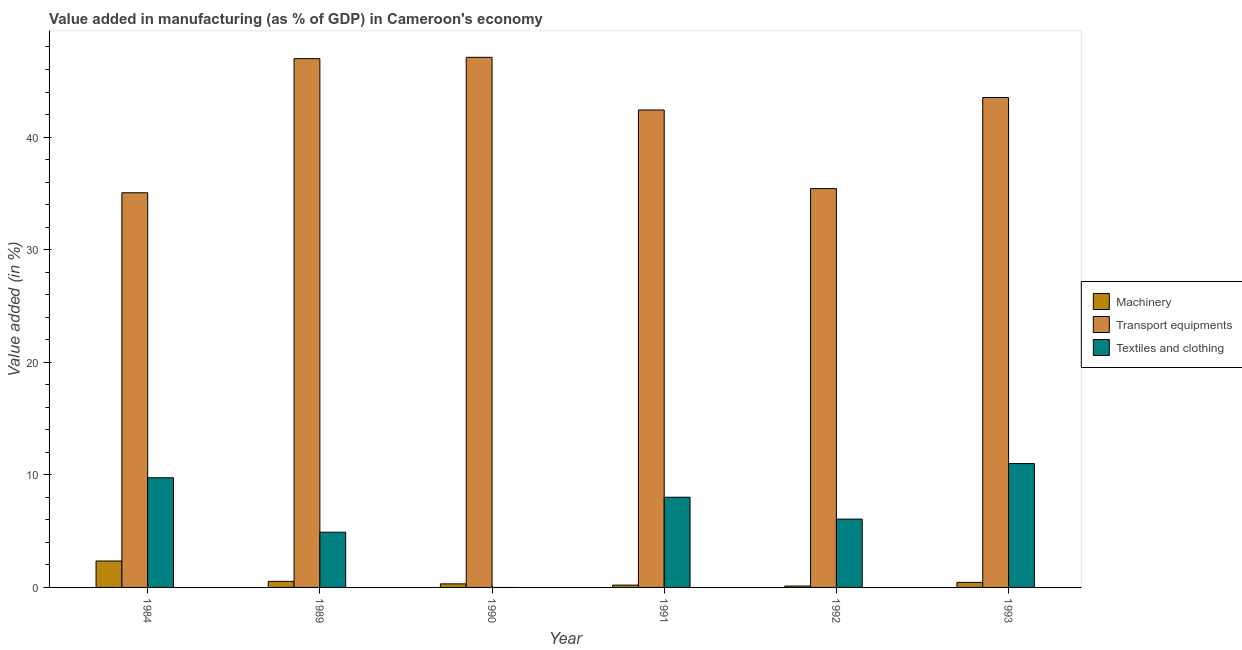Are the number of bars on each tick of the X-axis equal?
Provide a short and direct response. No. How many bars are there on the 6th tick from the left?
Ensure brevity in your answer.  3. How many bars are there on the 3rd tick from the right?
Provide a succinct answer. 3. What is the value added in manufacturing transport equipments in 1991?
Offer a very short reply. 42.4. Across all years, what is the maximum value added in manufacturing machinery?
Offer a terse response. 2.35. Across all years, what is the minimum value added in manufacturing transport equipments?
Keep it short and to the point. 35.05. What is the total value added in manufacturing machinery in the graph?
Give a very brief answer. 3.98. What is the difference between the value added in manufacturing transport equipments in 1990 and that in 1991?
Provide a short and direct response. 4.68. What is the difference between the value added in manufacturing textile and clothing in 1989 and the value added in manufacturing machinery in 1993?
Offer a very short reply. -6.1. What is the average value added in manufacturing transport equipments per year?
Provide a succinct answer. 41.74. What is the ratio of the value added in manufacturing machinery in 1989 to that in 1990?
Provide a short and direct response. 1.7. Is the value added in manufacturing textile and clothing in 1984 less than that in 1993?
Provide a succinct answer. Yes. What is the difference between the highest and the second highest value added in manufacturing machinery?
Your answer should be very brief. 1.81. What is the difference between the highest and the lowest value added in manufacturing machinery?
Your answer should be very brief. 2.22. In how many years, is the value added in manufacturing textile and clothing greater than the average value added in manufacturing textile and clothing taken over all years?
Provide a succinct answer. 3. Are all the bars in the graph horizontal?
Offer a terse response. No. What is the difference between two consecutive major ticks on the Y-axis?
Make the answer very short. 10. Does the graph contain any zero values?
Make the answer very short. Yes. Where does the legend appear in the graph?
Offer a terse response. Center right. How many legend labels are there?
Provide a short and direct response. 3. What is the title of the graph?
Make the answer very short. Value added in manufacturing (as % of GDP) in Cameroon's economy. Does "Natural Gas" appear as one of the legend labels in the graph?
Make the answer very short. No. What is the label or title of the X-axis?
Your response must be concise. Year. What is the label or title of the Y-axis?
Provide a short and direct response. Value added (in %). What is the Value added (in %) in Machinery in 1984?
Keep it short and to the point. 2.35. What is the Value added (in %) in Transport equipments in 1984?
Make the answer very short. 35.05. What is the Value added (in %) of Textiles and clothing in 1984?
Provide a short and direct response. 9.74. What is the Value added (in %) of Machinery in 1989?
Keep it short and to the point. 0.54. What is the Value added (in %) of Transport equipments in 1989?
Make the answer very short. 46.96. What is the Value added (in %) in Textiles and clothing in 1989?
Give a very brief answer. 4.9. What is the Value added (in %) in Machinery in 1990?
Offer a very short reply. 0.32. What is the Value added (in %) of Transport equipments in 1990?
Your answer should be very brief. 47.08. What is the Value added (in %) of Textiles and clothing in 1990?
Provide a succinct answer. 0. What is the Value added (in %) of Machinery in 1991?
Offer a terse response. 0.21. What is the Value added (in %) of Transport equipments in 1991?
Offer a terse response. 42.4. What is the Value added (in %) of Textiles and clothing in 1991?
Your response must be concise. 8.01. What is the Value added (in %) of Machinery in 1992?
Keep it short and to the point. 0.12. What is the Value added (in %) of Transport equipments in 1992?
Your answer should be very brief. 35.42. What is the Value added (in %) in Textiles and clothing in 1992?
Ensure brevity in your answer.  6.07. What is the Value added (in %) in Machinery in 1993?
Make the answer very short. 0.45. What is the Value added (in %) of Transport equipments in 1993?
Ensure brevity in your answer.  43.51. What is the Value added (in %) in Textiles and clothing in 1993?
Your response must be concise. 11. Across all years, what is the maximum Value added (in %) of Machinery?
Your response must be concise. 2.35. Across all years, what is the maximum Value added (in %) in Transport equipments?
Make the answer very short. 47.08. Across all years, what is the maximum Value added (in %) of Textiles and clothing?
Your response must be concise. 11. Across all years, what is the minimum Value added (in %) of Machinery?
Your answer should be compact. 0.12. Across all years, what is the minimum Value added (in %) of Transport equipments?
Ensure brevity in your answer.  35.05. Across all years, what is the minimum Value added (in %) in Textiles and clothing?
Make the answer very short. 0. What is the total Value added (in %) of Machinery in the graph?
Give a very brief answer. 3.98. What is the total Value added (in %) in Transport equipments in the graph?
Offer a terse response. 250.43. What is the total Value added (in %) in Textiles and clothing in the graph?
Keep it short and to the point. 39.72. What is the difference between the Value added (in %) in Machinery in 1984 and that in 1989?
Ensure brevity in your answer.  1.81. What is the difference between the Value added (in %) of Transport equipments in 1984 and that in 1989?
Your response must be concise. -11.91. What is the difference between the Value added (in %) of Textiles and clothing in 1984 and that in 1989?
Offer a terse response. 4.84. What is the difference between the Value added (in %) in Machinery in 1984 and that in 1990?
Your answer should be compact. 2.03. What is the difference between the Value added (in %) of Transport equipments in 1984 and that in 1990?
Offer a very short reply. -12.03. What is the difference between the Value added (in %) of Machinery in 1984 and that in 1991?
Your answer should be very brief. 2.14. What is the difference between the Value added (in %) of Transport equipments in 1984 and that in 1991?
Give a very brief answer. -7.35. What is the difference between the Value added (in %) of Textiles and clothing in 1984 and that in 1991?
Provide a succinct answer. 1.73. What is the difference between the Value added (in %) in Machinery in 1984 and that in 1992?
Offer a very short reply. 2.22. What is the difference between the Value added (in %) of Transport equipments in 1984 and that in 1992?
Provide a succinct answer. -0.37. What is the difference between the Value added (in %) of Textiles and clothing in 1984 and that in 1992?
Your answer should be very brief. 3.67. What is the difference between the Value added (in %) of Machinery in 1984 and that in 1993?
Your answer should be compact. 1.9. What is the difference between the Value added (in %) in Transport equipments in 1984 and that in 1993?
Keep it short and to the point. -8.46. What is the difference between the Value added (in %) of Textiles and clothing in 1984 and that in 1993?
Your answer should be very brief. -1.26. What is the difference between the Value added (in %) of Machinery in 1989 and that in 1990?
Provide a short and direct response. 0.22. What is the difference between the Value added (in %) of Transport equipments in 1989 and that in 1990?
Provide a short and direct response. -0.12. What is the difference between the Value added (in %) in Transport equipments in 1989 and that in 1991?
Offer a very short reply. 4.56. What is the difference between the Value added (in %) in Textiles and clothing in 1989 and that in 1991?
Provide a short and direct response. -3.11. What is the difference between the Value added (in %) of Machinery in 1989 and that in 1992?
Keep it short and to the point. 0.42. What is the difference between the Value added (in %) in Transport equipments in 1989 and that in 1992?
Ensure brevity in your answer.  11.54. What is the difference between the Value added (in %) of Textiles and clothing in 1989 and that in 1992?
Make the answer very short. -1.16. What is the difference between the Value added (in %) of Machinery in 1989 and that in 1993?
Your answer should be compact. 0.09. What is the difference between the Value added (in %) of Transport equipments in 1989 and that in 1993?
Offer a terse response. 3.45. What is the difference between the Value added (in %) of Textiles and clothing in 1989 and that in 1993?
Your answer should be compact. -6.1. What is the difference between the Value added (in %) in Machinery in 1990 and that in 1991?
Your answer should be very brief. 0.11. What is the difference between the Value added (in %) in Transport equipments in 1990 and that in 1991?
Your response must be concise. 4.68. What is the difference between the Value added (in %) of Machinery in 1990 and that in 1992?
Your response must be concise. 0.19. What is the difference between the Value added (in %) of Transport equipments in 1990 and that in 1992?
Your answer should be very brief. 11.66. What is the difference between the Value added (in %) of Machinery in 1990 and that in 1993?
Ensure brevity in your answer.  -0.13. What is the difference between the Value added (in %) of Transport equipments in 1990 and that in 1993?
Provide a succinct answer. 3.57. What is the difference between the Value added (in %) in Machinery in 1991 and that in 1992?
Offer a very short reply. 0.08. What is the difference between the Value added (in %) of Transport equipments in 1991 and that in 1992?
Provide a short and direct response. 6.98. What is the difference between the Value added (in %) in Textiles and clothing in 1991 and that in 1992?
Make the answer very short. 1.94. What is the difference between the Value added (in %) of Machinery in 1991 and that in 1993?
Offer a terse response. -0.24. What is the difference between the Value added (in %) in Transport equipments in 1991 and that in 1993?
Your response must be concise. -1.11. What is the difference between the Value added (in %) in Textiles and clothing in 1991 and that in 1993?
Offer a terse response. -2.99. What is the difference between the Value added (in %) of Machinery in 1992 and that in 1993?
Give a very brief answer. -0.33. What is the difference between the Value added (in %) of Transport equipments in 1992 and that in 1993?
Offer a very short reply. -8.09. What is the difference between the Value added (in %) of Textiles and clothing in 1992 and that in 1993?
Your answer should be very brief. -4.93. What is the difference between the Value added (in %) of Machinery in 1984 and the Value added (in %) of Transport equipments in 1989?
Provide a short and direct response. -44.62. What is the difference between the Value added (in %) of Machinery in 1984 and the Value added (in %) of Textiles and clothing in 1989?
Offer a very short reply. -2.56. What is the difference between the Value added (in %) in Transport equipments in 1984 and the Value added (in %) in Textiles and clothing in 1989?
Your response must be concise. 30.15. What is the difference between the Value added (in %) in Machinery in 1984 and the Value added (in %) in Transport equipments in 1990?
Offer a terse response. -44.73. What is the difference between the Value added (in %) of Machinery in 1984 and the Value added (in %) of Transport equipments in 1991?
Your response must be concise. -40.06. What is the difference between the Value added (in %) in Machinery in 1984 and the Value added (in %) in Textiles and clothing in 1991?
Provide a short and direct response. -5.66. What is the difference between the Value added (in %) of Transport equipments in 1984 and the Value added (in %) of Textiles and clothing in 1991?
Ensure brevity in your answer.  27.04. What is the difference between the Value added (in %) of Machinery in 1984 and the Value added (in %) of Transport equipments in 1992?
Provide a succinct answer. -33.08. What is the difference between the Value added (in %) of Machinery in 1984 and the Value added (in %) of Textiles and clothing in 1992?
Offer a terse response. -3.72. What is the difference between the Value added (in %) of Transport equipments in 1984 and the Value added (in %) of Textiles and clothing in 1992?
Your answer should be very brief. 28.98. What is the difference between the Value added (in %) of Machinery in 1984 and the Value added (in %) of Transport equipments in 1993?
Provide a short and direct response. -41.17. What is the difference between the Value added (in %) of Machinery in 1984 and the Value added (in %) of Textiles and clothing in 1993?
Your response must be concise. -8.65. What is the difference between the Value added (in %) in Transport equipments in 1984 and the Value added (in %) in Textiles and clothing in 1993?
Your answer should be compact. 24.05. What is the difference between the Value added (in %) of Machinery in 1989 and the Value added (in %) of Transport equipments in 1990?
Ensure brevity in your answer.  -46.54. What is the difference between the Value added (in %) in Machinery in 1989 and the Value added (in %) in Transport equipments in 1991?
Give a very brief answer. -41.86. What is the difference between the Value added (in %) in Machinery in 1989 and the Value added (in %) in Textiles and clothing in 1991?
Your response must be concise. -7.47. What is the difference between the Value added (in %) of Transport equipments in 1989 and the Value added (in %) of Textiles and clothing in 1991?
Give a very brief answer. 38.95. What is the difference between the Value added (in %) of Machinery in 1989 and the Value added (in %) of Transport equipments in 1992?
Give a very brief answer. -34.89. What is the difference between the Value added (in %) of Machinery in 1989 and the Value added (in %) of Textiles and clothing in 1992?
Your response must be concise. -5.53. What is the difference between the Value added (in %) of Transport equipments in 1989 and the Value added (in %) of Textiles and clothing in 1992?
Offer a very short reply. 40.9. What is the difference between the Value added (in %) in Machinery in 1989 and the Value added (in %) in Transport equipments in 1993?
Make the answer very short. -42.97. What is the difference between the Value added (in %) of Machinery in 1989 and the Value added (in %) of Textiles and clothing in 1993?
Provide a succinct answer. -10.46. What is the difference between the Value added (in %) of Transport equipments in 1989 and the Value added (in %) of Textiles and clothing in 1993?
Your answer should be very brief. 35.96. What is the difference between the Value added (in %) of Machinery in 1990 and the Value added (in %) of Transport equipments in 1991?
Your answer should be compact. -42.09. What is the difference between the Value added (in %) in Machinery in 1990 and the Value added (in %) in Textiles and clothing in 1991?
Keep it short and to the point. -7.69. What is the difference between the Value added (in %) of Transport equipments in 1990 and the Value added (in %) of Textiles and clothing in 1991?
Your response must be concise. 39.07. What is the difference between the Value added (in %) in Machinery in 1990 and the Value added (in %) in Transport equipments in 1992?
Your answer should be compact. -35.11. What is the difference between the Value added (in %) in Machinery in 1990 and the Value added (in %) in Textiles and clothing in 1992?
Give a very brief answer. -5.75. What is the difference between the Value added (in %) in Transport equipments in 1990 and the Value added (in %) in Textiles and clothing in 1992?
Offer a very short reply. 41.01. What is the difference between the Value added (in %) in Machinery in 1990 and the Value added (in %) in Transport equipments in 1993?
Your answer should be very brief. -43.2. What is the difference between the Value added (in %) in Machinery in 1990 and the Value added (in %) in Textiles and clothing in 1993?
Offer a terse response. -10.68. What is the difference between the Value added (in %) of Transport equipments in 1990 and the Value added (in %) of Textiles and clothing in 1993?
Your answer should be very brief. 36.08. What is the difference between the Value added (in %) in Machinery in 1991 and the Value added (in %) in Transport equipments in 1992?
Your answer should be compact. -35.22. What is the difference between the Value added (in %) of Machinery in 1991 and the Value added (in %) of Textiles and clothing in 1992?
Your response must be concise. -5.86. What is the difference between the Value added (in %) of Transport equipments in 1991 and the Value added (in %) of Textiles and clothing in 1992?
Your answer should be compact. 36.34. What is the difference between the Value added (in %) in Machinery in 1991 and the Value added (in %) in Transport equipments in 1993?
Your answer should be very brief. -43.31. What is the difference between the Value added (in %) of Machinery in 1991 and the Value added (in %) of Textiles and clothing in 1993?
Give a very brief answer. -10.79. What is the difference between the Value added (in %) in Transport equipments in 1991 and the Value added (in %) in Textiles and clothing in 1993?
Ensure brevity in your answer.  31.4. What is the difference between the Value added (in %) of Machinery in 1992 and the Value added (in %) of Transport equipments in 1993?
Provide a short and direct response. -43.39. What is the difference between the Value added (in %) in Machinery in 1992 and the Value added (in %) in Textiles and clothing in 1993?
Your answer should be compact. -10.88. What is the difference between the Value added (in %) in Transport equipments in 1992 and the Value added (in %) in Textiles and clothing in 1993?
Offer a very short reply. 24.43. What is the average Value added (in %) of Machinery per year?
Make the answer very short. 0.66. What is the average Value added (in %) in Transport equipments per year?
Your answer should be compact. 41.74. What is the average Value added (in %) in Textiles and clothing per year?
Your answer should be compact. 6.62. In the year 1984, what is the difference between the Value added (in %) in Machinery and Value added (in %) in Transport equipments?
Offer a terse response. -32.7. In the year 1984, what is the difference between the Value added (in %) in Machinery and Value added (in %) in Textiles and clothing?
Keep it short and to the point. -7.39. In the year 1984, what is the difference between the Value added (in %) of Transport equipments and Value added (in %) of Textiles and clothing?
Give a very brief answer. 25.31. In the year 1989, what is the difference between the Value added (in %) of Machinery and Value added (in %) of Transport equipments?
Offer a very short reply. -46.42. In the year 1989, what is the difference between the Value added (in %) of Machinery and Value added (in %) of Textiles and clothing?
Provide a short and direct response. -4.36. In the year 1989, what is the difference between the Value added (in %) in Transport equipments and Value added (in %) in Textiles and clothing?
Offer a very short reply. 42.06. In the year 1990, what is the difference between the Value added (in %) in Machinery and Value added (in %) in Transport equipments?
Your answer should be compact. -46.76. In the year 1991, what is the difference between the Value added (in %) of Machinery and Value added (in %) of Transport equipments?
Provide a succinct answer. -42.2. In the year 1991, what is the difference between the Value added (in %) in Machinery and Value added (in %) in Textiles and clothing?
Your answer should be very brief. -7.8. In the year 1991, what is the difference between the Value added (in %) in Transport equipments and Value added (in %) in Textiles and clothing?
Your answer should be compact. 34.39. In the year 1992, what is the difference between the Value added (in %) of Machinery and Value added (in %) of Transport equipments?
Make the answer very short. -35.3. In the year 1992, what is the difference between the Value added (in %) of Machinery and Value added (in %) of Textiles and clothing?
Your answer should be compact. -5.94. In the year 1992, what is the difference between the Value added (in %) in Transport equipments and Value added (in %) in Textiles and clothing?
Your response must be concise. 29.36. In the year 1993, what is the difference between the Value added (in %) in Machinery and Value added (in %) in Transport equipments?
Your response must be concise. -43.06. In the year 1993, what is the difference between the Value added (in %) in Machinery and Value added (in %) in Textiles and clothing?
Your answer should be compact. -10.55. In the year 1993, what is the difference between the Value added (in %) of Transport equipments and Value added (in %) of Textiles and clothing?
Your answer should be very brief. 32.51. What is the ratio of the Value added (in %) of Machinery in 1984 to that in 1989?
Your response must be concise. 4.35. What is the ratio of the Value added (in %) in Transport equipments in 1984 to that in 1989?
Your answer should be compact. 0.75. What is the ratio of the Value added (in %) in Textiles and clothing in 1984 to that in 1989?
Keep it short and to the point. 1.99. What is the ratio of the Value added (in %) in Machinery in 1984 to that in 1990?
Ensure brevity in your answer.  7.42. What is the ratio of the Value added (in %) of Transport equipments in 1984 to that in 1990?
Give a very brief answer. 0.74. What is the ratio of the Value added (in %) of Machinery in 1984 to that in 1991?
Your response must be concise. 11.41. What is the ratio of the Value added (in %) of Transport equipments in 1984 to that in 1991?
Give a very brief answer. 0.83. What is the ratio of the Value added (in %) of Textiles and clothing in 1984 to that in 1991?
Offer a very short reply. 1.22. What is the ratio of the Value added (in %) in Machinery in 1984 to that in 1992?
Offer a terse response. 19.08. What is the ratio of the Value added (in %) of Transport equipments in 1984 to that in 1992?
Your response must be concise. 0.99. What is the ratio of the Value added (in %) of Textiles and clothing in 1984 to that in 1992?
Make the answer very short. 1.61. What is the ratio of the Value added (in %) of Machinery in 1984 to that in 1993?
Provide a succinct answer. 5.23. What is the ratio of the Value added (in %) in Transport equipments in 1984 to that in 1993?
Ensure brevity in your answer.  0.81. What is the ratio of the Value added (in %) in Textiles and clothing in 1984 to that in 1993?
Ensure brevity in your answer.  0.89. What is the ratio of the Value added (in %) of Machinery in 1989 to that in 1990?
Your answer should be compact. 1.7. What is the ratio of the Value added (in %) in Transport equipments in 1989 to that in 1990?
Your answer should be very brief. 1. What is the ratio of the Value added (in %) in Machinery in 1989 to that in 1991?
Keep it short and to the point. 2.62. What is the ratio of the Value added (in %) of Transport equipments in 1989 to that in 1991?
Offer a very short reply. 1.11. What is the ratio of the Value added (in %) of Textiles and clothing in 1989 to that in 1991?
Your answer should be very brief. 0.61. What is the ratio of the Value added (in %) in Machinery in 1989 to that in 1992?
Give a very brief answer. 4.38. What is the ratio of the Value added (in %) of Transport equipments in 1989 to that in 1992?
Your answer should be very brief. 1.33. What is the ratio of the Value added (in %) of Textiles and clothing in 1989 to that in 1992?
Your answer should be very brief. 0.81. What is the ratio of the Value added (in %) of Machinery in 1989 to that in 1993?
Give a very brief answer. 1.2. What is the ratio of the Value added (in %) of Transport equipments in 1989 to that in 1993?
Your answer should be very brief. 1.08. What is the ratio of the Value added (in %) of Textiles and clothing in 1989 to that in 1993?
Give a very brief answer. 0.45. What is the ratio of the Value added (in %) in Machinery in 1990 to that in 1991?
Offer a very short reply. 1.54. What is the ratio of the Value added (in %) of Transport equipments in 1990 to that in 1991?
Your answer should be compact. 1.11. What is the ratio of the Value added (in %) of Machinery in 1990 to that in 1992?
Provide a succinct answer. 2.57. What is the ratio of the Value added (in %) in Transport equipments in 1990 to that in 1992?
Make the answer very short. 1.33. What is the ratio of the Value added (in %) in Machinery in 1990 to that in 1993?
Give a very brief answer. 0.7. What is the ratio of the Value added (in %) in Transport equipments in 1990 to that in 1993?
Your response must be concise. 1.08. What is the ratio of the Value added (in %) of Machinery in 1991 to that in 1992?
Your response must be concise. 1.67. What is the ratio of the Value added (in %) in Transport equipments in 1991 to that in 1992?
Your answer should be very brief. 1.2. What is the ratio of the Value added (in %) in Textiles and clothing in 1991 to that in 1992?
Offer a terse response. 1.32. What is the ratio of the Value added (in %) in Machinery in 1991 to that in 1993?
Offer a terse response. 0.46. What is the ratio of the Value added (in %) in Transport equipments in 1991 to that in 1993?
Your answer should be compact. 0.97. What is the ratio of the Value added (in %) in Textiles and clothing in 1991 to that in 1993?
Your response must be concise. 0.73. What is the ratio of the Value added (in %) of Machinery in 1992 to that in 1993?
Ensure brevity in your answer.  0.27. What is the ratio of the Value added (in %) in Transport equipments in 1992 to that in 1993?
Ensure brevity in your answer.  0.81. What is the ratio of the Value added (in %) of Textiles and clothing in 1992 to that in 1993?
Your answer should be compact. 0.55. What is the difference between the highest and the second highest Value added (in %) of Machinery?
Provide a succinct answer. 1.81. What is the difference between the highest and the second highest Value added (in %) of Transport equipments?
Ensure brevity in your answer.  0.12. What is the difference between the highest and the second highest Value added (in %) in Textiles and clothing?
Your answer should be compact. 1.26. What is the difference between the highest and the lowest Value added (in %) of Machinery?
Offer a terse response. 2.22. What is the difference between the highest and the lowest Value added (in %) in Transport equipments?
Your answer should be very brief. 12.03. What is the difference between the highest and the lowest Value added (in %) of Textiles and clothing?
Make the answer very short. 11. 